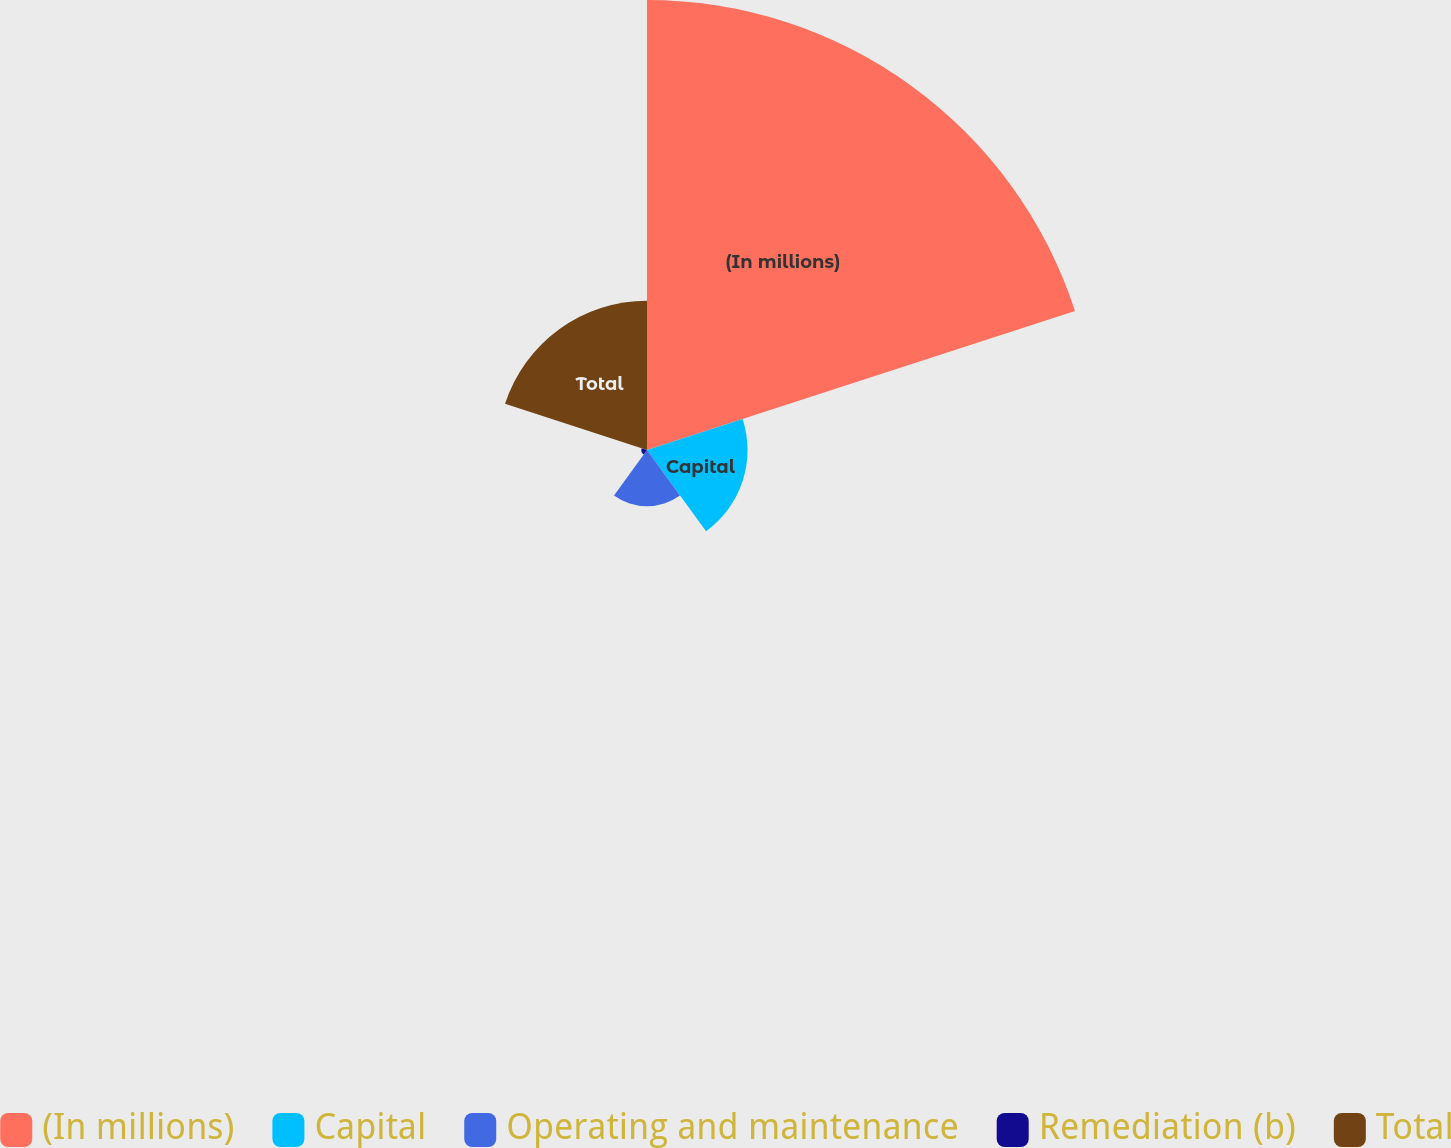Convert chart to OTSL. <chart><loc_0><loc_0><loc_500><loc_500><pie_chart><fcel>(In millions)<fcel>Capital<fcel>Operating and maintenance<fcel>Remediation (b)<fcel>Total<nl><fcel>59.09%<fcel>13.2%<fcel>7.37%<fcel>0.74%<fcel>19.6%<nl></chart> 